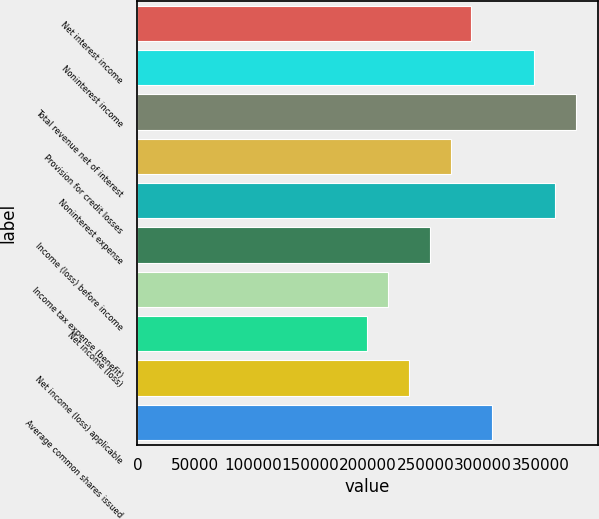Convert chart. <chart><loc_0><loc_0><loc_500><loc_500><bar_chart><fcel>Net interest income<fcel>Noninterest income<fcel>Total revenue net of interest<fcel>Provision for credit losses<fcel>Noninterest expense<fcel>Income (loss) before income<fcel>Income tax expense (benefit)<fcel>Net income (loss)<fcel>Net income (loss) applicable<fcel>Average common shares issued<nl><fcel>289787<fcel>344122<fcel>380346<fcel>271676<fcel>362234<fcel>253564<fcel>217340<fcel>199229<fcel>235452<fcel>307899<nl></chart> 